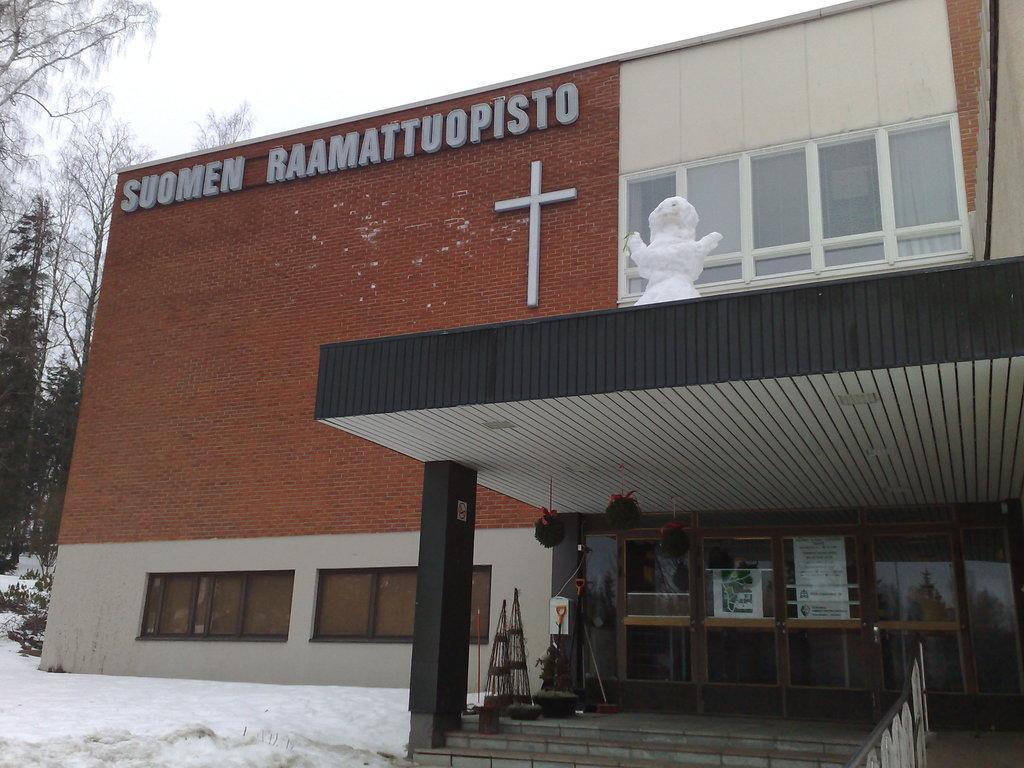How would you summarize this image in a sentence or two? In the picture we can see a prayer hall building with a cross symbol on the wall of the building and we can see some glass windows and doors to it and inside the building we can see some trees and snow surface and in the background we can see a sky. 